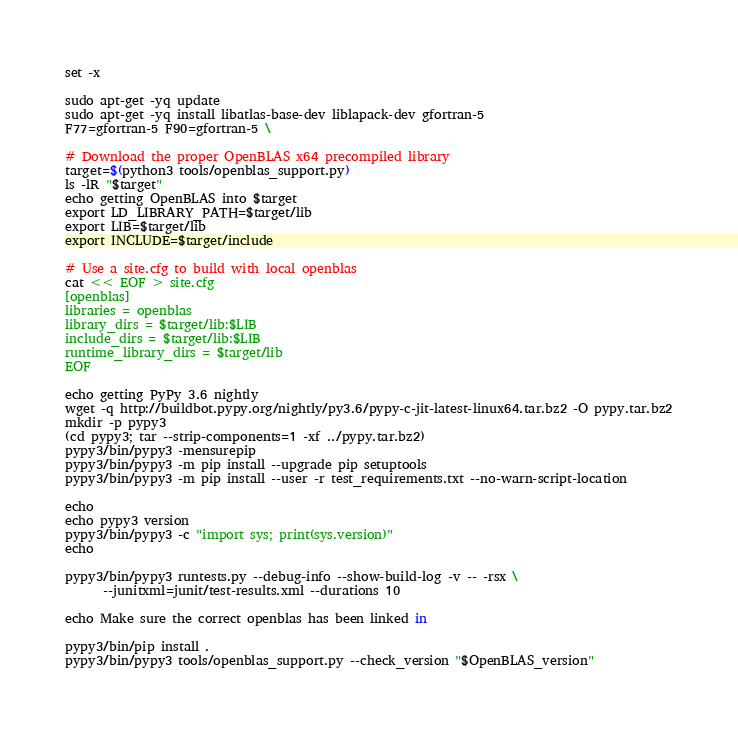Convert code to text. <code><loc_0><loc_0><loc_500><loc_500><_Bash_>set -x

sudo apt-get -yq update
sudo apt-get -yq install libatlas-base-dev liblapack-dev gfortran-5
F77=gfortran-5 F90=gfortran-5 \

# Download the proper OpenBLAS x64 precompiled library
target=$(python3 tools/openblas_support.py)
ls -lR "$target"
echo getting OpenBLAS into $target
export LD_LIBRARY_PATH=$target/lib
export LIB=$target/lib
export INCLUDE=$target/include

# Use a site.cfg to build with local openblas
cat << EOF > site.cfg
[openblas]
libraries = openblas
library_dirs = $target/lib:$LIB
include_dirs = $target/lib:$LIB
runtime_library_dirs = $target/lib
EOF

echo getting PyPy 3.6 nightly
wget -q http://buildbot.pypy.org/nightly/py3.6/pypy-c-jit-latest-linux64.tar.bz2 -O pypy.tar.bz2
mkdir -p pypy3
(cd pypy3; tar --strip-components=1 -xf ../pypy.tar.bz2)
pypy3/bin/pypy3 -mensurepip
pypy3/bin/pypy3 -m pip install --upgrade pip setuptools
pypy3/bin/pypy3 -m pip install --user -r test_requirements.txt --no-warn-script-location

echo
echo pypy3 version 
pypy3/bin/pypy3 -c "import sys; print(sys.version)"
echo

pypy3/bin/pypy3 runtests.py --debug-info --show-build-log -v -- -rsx \
      --junitxml=junit/test-results.xml --durations 10

echo Make sure the correct openblas has been linked in

pypy3/bin/pip install .
pypy3/bin/pypy3 tools/openblas_support.py --check_version "$OpenBLAS_version"
</code> 